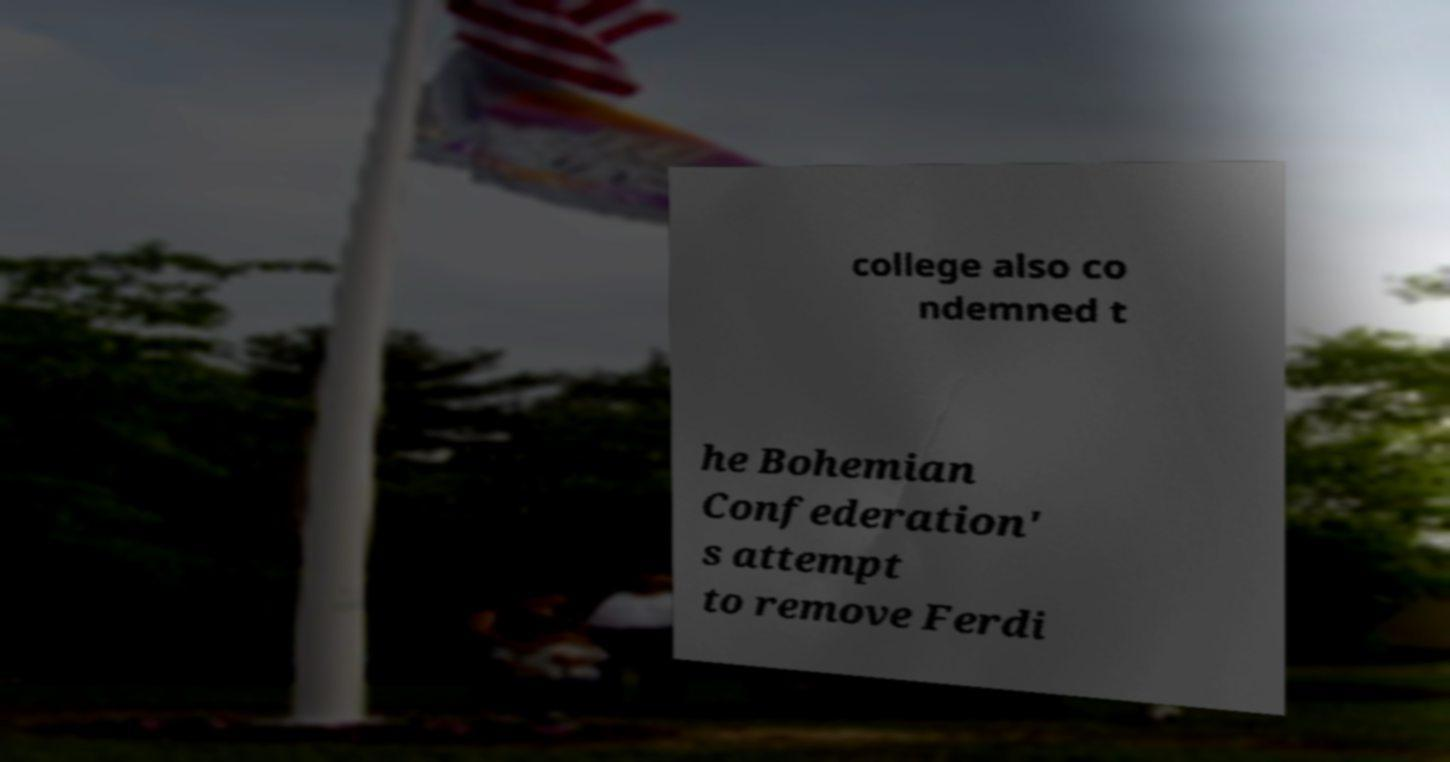Could you assist in decoding the text presented in this image and type it out clearly? college also co ndemned t he Bohemian Confederation' s attempt to remove Ferdi 